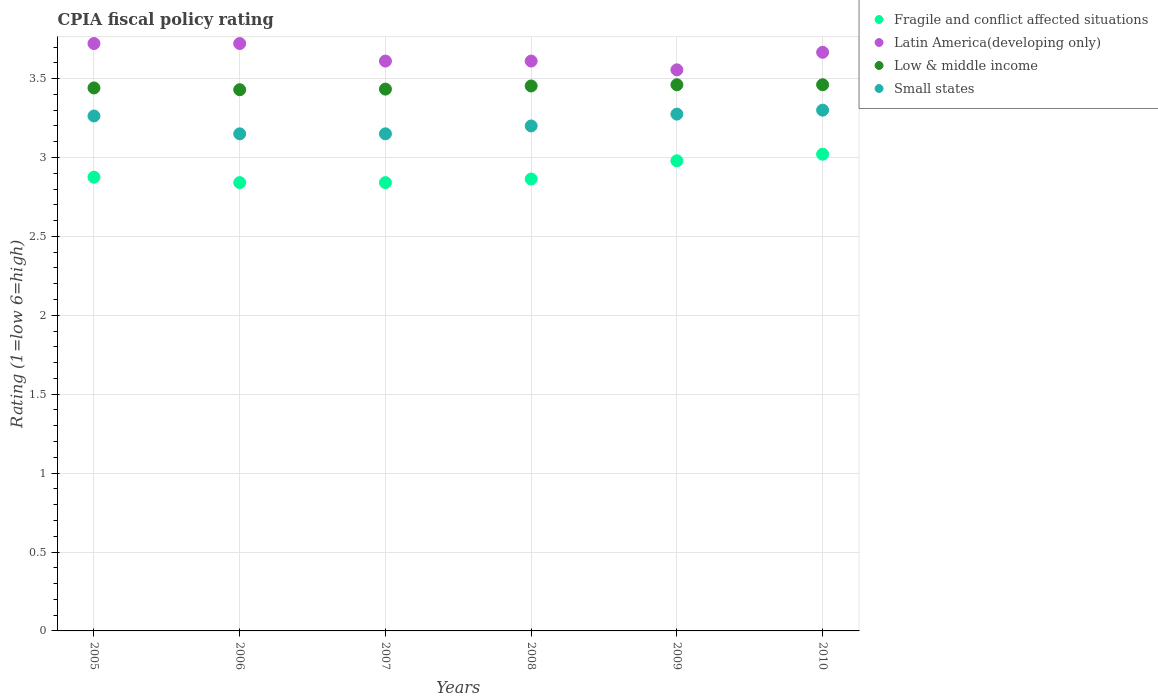How many different coloured dotlines are there?
Your response must be concise. 4. What is the CPIA rating in Low & middle income in 2006?
Offer a terse response. 3.43. Across all years, what is the minimum CPIA rating in Small states?
Your answer should be compact. 3.15. In which year was the CPIA rating in Small states minimum?
Provide a short and direct response. 2006. What is the total CPIA rating in Low & middle income in the graph?
Provide a short and direct response. 20.68. What is the difference between the CPIA rating in Latin America(developing only) in 2006 and that in 2008?
Keep it short and to the point. 0.11. What is the difference between the CPIA rating in Low & middle income in 2009 and the CPIA rating in Latin America(developing only) in 2010?
Offer a very short reply. -0.21. What is the average CPIA rating in Fragile and conflict affected situations per year?
Your answer should be very brief. 2.9. In the year 2006, what is the difference between the CPIA rating in Small states and CPIA rating in Low & middle income?
Ensure brevity in your answer.  -0.28. In how many years, is the CPIA rating in Low & middle income greater than 1.8?
Ensure brevity in your answer.  6. What is the ratio of the CPIA rating in Latin America(developing only) in 2009 to that in 2010?
Your response must be concise. 0.97. Is the difference between the CPIA rating in Small states in 2005 and 2007 greater than the difference between the CPIA rating in Low & middle income in 2005 and 2007?
Offer a terse response. Yes. What is the difference between the highest and the second highest CPIA rating in Fragile and conflict affected situations?
Give a very brief answer. 0.04. What is the difference between the highest and the lowest CPIA rating in Latin America(developing only)?
Offer a very short reply. 0.17. In how many years, is the CPIA rating in Fragile and conflict affected situations greater than the average CPIA rating in Fragile and conflict affected situations taken over all years?
Keep it short and to the point. 2. Is the sum of the CPIA rating in Low & middle income in 2008 and 2010 greater than the maximum CPIA rating in Latin America(developing only) across all years?
Ensure brevity in your answer.  Yes. Is it the case that in every year, the sum of the CPIA rating in Fragile and conflict affected situations and CPIA rating in Small states  is greater than the CPIA rating in Low & middle income?
Offer a very short reply. Yes. Is the CPIA rating in Low & middle income strictly greater than the CPIA rating in Latin America(developing only) over the years?
Keep it short and to the point. No. How many years are there in the graph?
Provide a short and direct response. 6. What is the difference between two consecutive major ticks on the Y-axis?
Provide a succinct answer. 0.5. Are the values on the major ticks of Y-axis written in scientific E-notation?
Give a very brief answer. No. Where does the legend appear in the graph?
Your answer should be compact. Top right. How are the legend labels stacked?
Make the answer very short. Vertical. What is the title of the graph?
Ensure brevity in your answer.  CPIA fiscal policy rating. Does "Middle income" appear as one of the legend labels in the graph?
Offer a terse response. No. What is the label or title of the X-axis?
Offer a very short reply. Years. What is the label or title of the Y-axis?
Offer a very short reply. Rating (1=low 6=high). What is the Rating (1=low 6=high) in Fragile and conflict affected situations in 2005?
Ensure brevity in your answer.  2.88. What is the Rating (1=low 6=high) of Latin America(developing only) in 2005?
Give a very brief answer. 3.72. What is the Rating (1=low 6=high) of Low & middle income in 2005?
Give a very brief answer. 3.44. What is the Rating (1=low 6=high) of Small states in 2005?
Provide a short and direct response. 3.26. What is the Rating (1=low 6=high) in Fragile and conflict affected situations in 2006?
Offer a very short reply. 2.84. What is the Rating (1=low 6=high) in Latin America(developing only) in 2006?
Make the answer very short. 3.72. What is the Rating (1=low 6=high) of Low & middle income in 2006?
Keep it short and to the point. 3.43. What is the Rating (1=low 6=high) in Small states in 2006?
Offer a terse response. 3.15. What is the Rating (1=low 6=high) of Fragile and conflict affected situations in 2007?
Your answer should be very brief. 2.84. What is the Rating (1=low 6=high) in Latin America(developing only) in 2007?
Make the answer very short. 3.61. What is the Rating (1=low 6=high) of Low & middle income in 2007?
Offer a terse response. 3.43. What is the Rating (1=low 6=high) in Small states in 2007?
Offer a terse response. 3.15. What is the Rating (1=low 6=high) of Fragile and conflict affected situations in 2008?
Give a very brief answer. 2.86. What is the Rating (1=low 6=high) of Latin America(developing only) in 2008?
Provide a short and direct response. 3.61. What is the Rating (1=low 6=high) of Low & middle income in 2008?
Your answer should be very brief. 3.45. What is the Rating (1=low 6=high) of Fragile and conflict affected situations in 2009?
Your answer should be very brief. 2.98. What is the Rating (1=low 6=high) in Latin America(developing only) in 2009?
Provide a short and direct response. 3.56. What is the Rating (1=low 6=high) of Low & middle income in 2009?
Offer a terse response. 3.46. What is the Rating (1=low 6=high) of Small states in 2009?
Ensure brevity in your answer.  3.27. What is the Rating (1=low 6=high) of Fragile and conflict affected situations in 2010?
Provide a short and direct response. 3.02. What is the Rating (1=low 6=high) in Latin America(developing only) in 2010?
Your response must be concise. 3.67. What is the Rating (1=low 6=high) of Low & middle income in 2010?
Your response must be concise. 3.46. What is the Rating (1=low 6=high) of Small states in 2010?
Offer a terse response. 3.3. Across all years, what is the maximum Rating (1=low 6=high) in Fragile and conflict affected situations?
Provide a succinct answer. 3.02. Across all years, what is the maximum Rating (1=low 6=high) in Latin America(developing only)?
Your answer should be compact. 3.72. Across all years, what is the maximum Rating (1=low 6=high) in Low & middle income?
Your answer should be compact. 3.46. Across all years, what is the minimum Rating (1=low 6=high) in Fragile and conflict affected situations?
Provide a succinct answer. 2.84. Across all years, what is the minimum Rating (1=low 6=high) of Latin America(developing only)?
Your answer should be compact. 3.56. Across all years, what is the minimum Rating (1=low 6=high) in Low & middle income?
Ensure brevity in your answer.  3.43. Across all years, what is the minimum Rating (1=low 6=high) of Small states?
Ensure brevity in your answer.  3.15. What is the total Rating (1=low 6=high) in Fragile and conflict affected situations in the graph?
Provide a short and direct response. 17.42. What is the total Rating (1=low 6=high) in Latin America(developing only) in the graph?
Keep it short and to the point. 21.89. What is the total Rating (1=low 6=high) in Low & middle income in the graph?
Keep it short and to the point. 20.68. What is the total Rating (1=low 6=high) in Small states in the graph?
Provide a short and direct response. 19.34. What is the difference between the Rating (1=low 6=high) of Fragile and conflict affected situations in 2005 and that in 2006?
Keep it short and to the point. 0.03. What is the difference between the Rating (1=low 6=high) in Low & middle income in 2005 and that in 2006?
Offer a very short reply. 0.01. What is the difference between the Rating (1=low 6=high) of Small states in 2005 and that in 2006?
Offer a very short reply. 0.11. What is the difference between the Rating (1=low 6=high) in Fragile and conflict affected situations in 2005 and that in 2007?
Provide a succinct answer. 0.03. What is the difference between the Rating (1=low 6=high) of Low & middle income in 2005 and that in 2007?
Make the answer very short. 0.01. What is the difference between the Rating (1=low 6=high) in Small states in 2005 and that in 2007?
Your answer should be compact. 0.11. What is the difference between the Rating (1=low 6=high) of Fragile and conflict affected situations in 2005 and that in 2008?
Give a very brief answer. 0.01. What is the difference between the Rating (1=low 6=high) in Low & middle income in 2005 and that in 2008?
Your response must be concise. -0.01. What is the difference between the Rating (1=low 6=high) of Small states in 2005 and that in 2008?
Your response must be concise. 0.06. What is the difference between the Rating (1=low 6=high) of Fragile and conflict affected situations in 2005 and that in 2009?
Provide a succinct answer. -0.1. What is the difference between the Rating (1=low 6=high) in Low & middle income in 2005 and that in 2009?
Keep it short and to the point. -0.02. What is the difference between the Rating (1=low 6=high) of Small states in 2005 and that in 2009?
Your answer should be very brief. -0.01. What is the difference between the Rating (1=low 6=high) in Fragile and conflict affected situations in 2005 and that in 2010?
Offer a terse response. -0.15. What is the difference between the Rating (1=low 6=high) in Latin America(developing only) in 2005 and that in 2010?
Give a very brief answer. 0.06. What is the difference between the Rating (1=low 6=high) of Low & middle income in 2005 and that in 2010?
Give a very brief answer. -0.02. What is the difference between the Rating (1=low 6=high) in Small states in 2005 and that in 2010?
Your answer should be compact. -0.04. What is the difference between the Rating (1=low 6=high) of Low & middle income in 2006 and that in 2007?
Offer a very short reply. -0. What is the difference between the Rating (1=low 6=high) of Small states in 2006 and that in 2007?
Keep it short and to the point. 0. What is the difference between the Rating (1=low 6=high) in Fragile and conflict affected situations in 2006 and that in 2008?
Offer a very short reply. -0.02. What is the difference between the Rating (1=low 6=high) in Latin America(developing only) in 2006 and that in 2008?
Give a very brief answer. 0.11. What is the difference between the Rating (1=low 6=high) of Low & middle income in 2006 and that in 2008?
Your answer should be compact. -0.02. What is the difference between the Rating (1=low 6=high) of Fragile and conflict affected situations in 2006 and that in 2009?
Keep it short and to the point. -0.14. What is the difference between the Rating (1=low 6=high) in Low & middle income in 2006 and that in 2009?
Offer a terse response. -0.03. What is the difference between the Rating (1=low 6=high) of Small states in 2006 and that in 2009?
Give a very brief answer. -0.12. What is the difference between the Rating (1=low 6=high) of Fragile and conflict affected situations in 2006 and that in 2010?
Keep it short and to the point. -0.18. What is the difference between the Rating (1=low 6=high) of Latin America(developing only) in 2006 and that in 2010?
Give a very brief answer. 0.06. What is the difference between the Rating (1=low 6=high) in Low & middle income in 2006 and that in 2010?
Ensure brevity in your answer.  -0.03. What is the difference between the Rating (1=low 6=high) of Fragile and conflict affected situations in 2007 and that in 2008?
Provide a short and direct response. -0.02. What is the difference between the Rating (1=low 6=high) of Latin America(developing only) in 2007 and that in 2008?
Offer a very short reply. 0. What is the difference between the Rating (1=low 6=high) of Low & middle income in 2007 and that in 2008?
Your response must be concise. -0.02. What is the difference between the Rating (1=low 6=high) of Small states in 2007 and that in 2008?
Your response must be concise. -0.05. What is the difference between the Rating (1=low 6=high) of Fragile and conflict affected situations in 2007 and that in 2009?
Keep it short and to the point. -0.14. What is the difference between the Rating (1=low 6=high) of Latin America(developing only) in 2007 and that in 2009?
Provide a succinct answer. 0.06. What is the difference between the Rating (1=low 6=high) of Low & middle income in 2007 and that in 2009?
Your answer should be compact. -0.03. What is the difference between the Rating (1=low 6=high) in Small states in 2007 and that in 2009?
Give a very brief answer. -0.12. What is the difference between the Rating (1=low 6=high) of Fragile and conflict affected situations in 2007 and that in 2010?
Ensure brevity in your answer.  -0.18. What is the difference between the Rating (1=low 6=high) of Latin America(developing only) in 2007 and that in 2010?
Make the answer very short. -0.06. What is the difference between the Rating (1=low 6=high) of Low & middle income in 2007 and that in 2010?
Your answer should be compact. -0.03. What is the difference between the Rating (1=low 6=high) in Small states in 2007 and that in 2010?
Keep it short and to the point. -0.15. What is the difference between the Rating (1=low 6=high) in Fragile and conflict affected situations in 2008 and that in 2009?
Provide a short and direct response. -0.12. What is the difference between the Rating (1=low 6=high) of Latin America(developing only) in 2008 and that in 2009?
Keep it short and to the point. 0.06. What is the difference between the Rating (1=low 6=high) of Low & middle income in 2008 and that in 2009?
Keep it short and to the point. -0.01. What is the difference between the Rating (1=low 6=high) in Small states in 2008 and that in 2009?
Keep it short and to the point. -0.07. What is the difference between the Rating (1=low 6=high) in Fragile and conflict affected situations in 2008 and that in 2010?
Offer a terse response. -0.16. What is the difference between the Rating (1=low 6=high) of Latin America(developing only) in 2008 and that in 2010?
Offer a very short reply. -0.06. What is the difference between the Rating (1=low 6=high) of Low & middle income in 2008 and that in 2010?
Your answer should be very brief. -0.01. What is the difference between the Rating (1=low 6=high) in Fragile and conflict affected situations in 2009 and that in 2010?
Your answer should be compact. -0.04. What is the difference between the Rating (1=low 6=high) of Latin America(developing only) in 2009 and that in 2010?
Offer a very short reply. -0.11. What is the difference between the Rating (1=low 6=high) of Low & middle income in 2009 and that in 2010?
Provide a succinct answer. 0. What is the difference between the Rating (1=low 6=high) in Small states in 2009 and that in 2010?
Offer a very short reply. -0.03. What is the difference between the Rating (1=low 6=high) in Fragile and conflict affected situations in 2005 and the Rating (1=low 6=high) in Latin America(developing only) in 2006?
Offer a very short reply. -0.85. What is the difference between the Rating (1=low 6=high) in Fragile and conflict affected situations in 2005 and the Rating (1=low 6=high) in Low & middle income in 2006?
Keep it short and to the point. -0.55. What is the difference between the Rating (1=low 6=high) in Fragile and conflict affected situations in 2005 and the Rating (1=low 6=high) in Small states in 2006?
Offer a terse response. -0.28. What is the difference between the Rating (1=low 6=high) in Latin America(developing only) in 2005 and the Rating (1=low 6=high) in Low & middle income in 2006?
Keep it short and to the point. 0.29. What is the difference between the Rating (1=low 6=high) in Latin America(developing only) in 2005 and the Rating (1=low 6=high) in Small states in 2006?
Ensure brevity in your answer.  0.57. What is the difference between the Rating (1=low 6=high) of Low & middle income in 2005 and the Rating (1=low 6=high) of Small states in 2006?
Make the answer very short. 0.29. What is the difference between the Rating (1=low 6=high) of Fragile and conflict affected situations in 2005 and the Rating (1=low 6=high) of Latin America(developing only) in 2007?
Offer a terse response. -0.74. What is the difference between the Rating (1=low 6=high) of Fragile and conflict affected situations in 2005 and the Rating (1=low 6=high) of Low & middle income in 2007?
Your answer should be very brief. -0.56. What is the difference between the Rating (1=low 6=high) of Fragile and conflict affected situations in 2005 and the Rating (1=low 6=high) of Small states in 2007?
Keep it short and to the point. -0.28. What is the difference between the Rating (1=low 6=high) of Latin America(developing only) in 2005 and the Rating (1=low 6=high) of Low & middle income in 2007?
Provide a succinct answer. 0.29. What is the difference between the Rating (1=low 6=high) in Latin America(developing only) in 2005 and the Rating (1=low 6=high) in Small states in 2007?
Your answer should be very brief. 0.57. What is the difference between the Rating (1=low 6=high) of Low & middle income in 2005 and the Rating (1=low 6=high) of Small states in 2007?
Make the answer very short. 0.29. What is the difference between the Rating (1=low 6=high) of Fragile and conflict affected situations in 2005 and the Rating (1=low 6=high) of Latin America(developing only) in 2008?
Provide a short and direct response. -0.74. What is the difference between the Rating (1=low 6=high) in Fragile and conflict affected situations in 2005 and the Rating (1=low 6=high) in Low & middle income in 2008?
Offer a terse response. -0.58. What is the difference between the Rating (1=low 6=high) in Fragile and conflict affected situations in 2005 and the Rating (1=low 6=high) in Small states in 2008?
Offer a terse response. -0.33. What is the difference between the Rating (1=low 6=high) in Latin America(developing only) in 2005 and the Rating (1=low 6=high) in Low & middle income in 2008?
Ensure brevity in your answer.  0.27. What is the difference between the Rating (1=low 6=high) of Latin America(developing only) in 2005 and the Rating (1=low 6=high) of Small states in 2008?
Your answer should be compact. 0.52. What is the difference between the Rating (1=low 6=high) of Low & middle income in 2005 and the Rating (1=low 6=high) of Small states in 2008?
Make the answer very short. 0.24. What is the difference between the Rating (1=low 6=high) of Fragile and conflict affected situations in 2005 and the Rating (1=low 6=high) of Latin America(developing only) in 2009?
Keep it short and to the point. -0.68. What is the difference between the Rating (1=low 6=high) of Fragile and conflict affected situations in 2005 and the Rating (1=low 6=high) of Low & middle income in 2009?
Your answer should be very brief. -0.59. What is the difference between the Rating (1=low 6=high) of Fragile and conflict affected situations in 2005 and the Rating (1=low 6=high) of Small states in 2009?
Offer a very short reply. -0.4. What is the difference between the Rating (1=low 6=high) in Latin America(developing only) in 2005 and the Rating (1=low 6=high) in Low & middle income in 2009?
Ensure brevity in your answer.  0.26. What is the difference between the Rating (1=low 6=high) of Latin America(developing only) in 2005 and the Rating (1=low 6=high) of Small states in 2009?
Offer a very short reply. 0.45. What is the difference between the Rating (1=low 6=high) in Low & middle income in 2005 and the Rating (1=low 6=high) in Small states in 2009?
Offer a very short reply. 0.17. What is the difference between the Rating (1=low 6=high) in Fragile and conflict affected situations in 2005 and the Rating (1=low 6=high) in Latin America(developing only) in 2010?
Make the answer very short. -0.79. What is the difference between the Rating (1=low 6=high) in Fragile and conflict affected situations in 2005 and the Rating (1=low 6=high) in Low & middle income in 2010?
Keep it short and to the point. -0.59. What is the difference between the Rating (1=low 6=high) in Fragile and conflict affected situations in 2005 and the Rating (1=low 6=high) in Small states in 2010?
Your answer should be very brief. -0.42. What is the difference between the Rating (1=low 6=high) in Latin America(developing only) in 2005 and the Rating (1=low 6=high) in Low & middle income in 2010?
Keep it short and to the point. 0.26. What is the difference between the Rating (1=low 6=high) in Latin America(developing only) in 2005 and the Rating (1=low 6=high) in Small states in 2010?
Offer a very short reply. 0.42. What is the difference between the Rating (1=low 6=high) in Low & middle income in 2005 and the Rating (1=low 6=high) in Small states in 2010?
Offer a very short reply. 0.14. What is the difference between the Rating (1=low 6=high) of Fragile and conflict affected situations in 2006 and the Rating (1=low 6=high) of Latin America(developing only) in 2007?
Ensure brevity in your answer.  -0.77. What is the difference between the Rating (1=low 6=high) in Fragile and conflict affected situations in 2006 and the Rating (1=low 6=high) in Low & middle income in 2007?
Provide a short and direct response. -0.59. What is the difference between the Rating (1=low 6=high) of Fragile and conflict affected situations in 2006 and the Rating (1=low 6=high) of Small states in 2007?
Ensure brevity in your answer.  -0.31. What is the difference between the Rating (1=low 6=high) of Latin America(developing only) in 2006 and the Rating (1=low 6=high) of Low & middle income in 2007?
Keep it short and to the point. 0.29. What is the difference between the Rating (1=low 6=high) in Latin America(developing only) in 2006 and the Rating (1=low 6=high) in Small states in 2007?
Your answer should be compact. 0.57. What is the difference between the Rating (1=low 6=high) of Low & middle income in 2006 and the Rating (1=low 6=high) of Small states in 2007?
Your answer should be very brief. 0.28. What is the difference between the Rating (1=low 6=high) of Fragile and conflict affected situations in 2006 and the Rating (1=low 6=high) of Latin America(developing only) in 2008?
Ensure brevity in your answer.  -0.77. What is the difference between the Rating (1=low 6=high) in Fragile and conflict affected situations in 2006 and the Rating (1=low 6=high) in Low & middle income in 2008?
Provide a short and direct response. -0.61. What is the difference between the Rating (1=low 6=high) in Fragile and conflict affected situations in 2006 and the Rating (1=low 6=high) in Small states in 2008?
Keep it short and to the point. -0.36. What is the difference between the Rating (1=low 6=high) of Latin America(developing only) in 2006 and the Rating (1=low 6=high) of Low & middle income in 2008?
Provide a succinct answer. 0.27. What is the difference between the Rating (1=low 6=high) in Latin America(developing only) in 2006 and the Rating (1=low 6=high) in Small states in 2008?
Your answer should be very brief. 0.52. What is the difference between the Rating (1=low 6=high) in Low & middle income in 2006 and the Rating (1=low 6=high) in Small states in 2008?
Offer a terse response. 0.23. What is the difference between the Rating (1=low 6=high) in Fragile and conflict affected situations in 2006 and the Rating (1=low 6=high) in Latin America(developing only) in 2009?
Ensure brevity in your answer.  -0.71. What is the difference between the Rating (1=low 6=high) of Fragile and conflict affected situations in 2006 and the Rating (1=low 6=high) of Low & middle income in 2009?
Provide a succinct answer. -0.62. What is the difference between the Rating (1=low 6=high) of Fragile and conflict affected situations in 2006 and the Rating (1=low 6=high) of Small states in 2009?
Your answer should be compact. -0.43. What is the difference between the Rating (1=low 6=high) in Latin America(developing only) in 2006 and the Rating (1=low 6=high) in Low & middle income in 2009?
Keep it short and to the point. 0.26. What is the difference between the Rating (1=low 6=high) in Latin America(developing only) in 2006 and the Rating (1=low 6=high) in Small states in 2009?
Keep it short and to the point. 0.45. What is the difference between the Rating (1=low 6=high) of Low & middle income in 2006 and the Rating (1=low 6=high) of Small states in 2009?
Keep it short and to the point. 0.15. What is the difference between the Rating (1=low 6=high) in Fragile and conflict affected situations in 2006 and the Rating (1=low 6=high) in Latin America(developing only) in 2010?
Offer a very short reply. -0.83. What is the difference between the Rating (1=low 6=high) in Fragile and conflict affected situations in 2006 and the Rating (1=low 6=high) in Low & middle income in 2010?
Provide a succinct answer. -0.62. What is the difference between the Rating (1=low 6=high) of Fragile and conflict affected situations in 2006 and the Rating (1=low 6=high) of Small states in 2010?
Keep it short and to the point. -0.46. What is the difference between the Rating (1=low 6=high) in Latin America(developing only) in 2006 and the Rating (1=low 6=high) in Low & middle income in 2010?
Ensure brevity in your answer.  0.26. What is the difference between the Rating (1=low 6=high) in Latin America(developing only) in 2006 and the Rating (1=low 6=high) in Small states in 2010?
Your answer should be compact. 0.42. What is the difference between the Rating (1=low 6=high) of Low & middle income in 2006 and the Rating (1=low 6=high) of Small states in 2010?
Keep it short and to the point. 0.13. What is the difference between the Rating (1=low 6=high) in Fragile and conflict affected situations in 2007 and the Rating (1=low 6=high) in Latin America(developing only) in 2008?
Offer a very short reply. -0.77. What is the difference between the Rating (1=low 6=high) in Fragile and conflict affected situations in 2007 and the Rating (1=low 6=high) in Low & middle income in 2008?
Your answer should be very brief. -0.61. What is the difference between the Rating (1=low 6=high) in Fragile and conflict affected situations in 2007 and the Rating (1=low 6=high) in Small states in 2008?
Provide a succinct answer. -0.36. What is the difference between the Rating (1=low 6=high) in Latin America(developing only) in 2007 and the Rating (1=low 6=high) in Low & middle income in 2008?
Make the answer very short. 0.16. What is the difference between the Rating (1=low 6=high) in Latin America(developing only) in 2007 and the Rating (1=low 6=high) in Small states in 2008?
Provide a short and direct response. 0.41. What is the difference between the Rating (1=low 6=high) in Low & middle income in 2007 and the Rating (1=low 6=high) in Small states in 2008?
Your answer should be compact. 0.23. What is the difference between the Rating (1=low 6=high) of Fragile and conflict affected situations in 2007 and the Rating (1=low 6=high) of Latin America(developing only) in 2009?
Provide a succinct answer. -0.71. What is the difference between the Rating (1=low 6=high) in Fragile and conflict affected situations in 2007 and the Rating (1=low 6=high) in Low & middle income in 2009?
Make the answer very short. -0.62. What is the difference between the Rating (1=low 6=high) of Fragile and conflict affected situations in 2007 and the Rating (1=low 6=high) of Small states in 2009?
Ensure brevity in your answer.  -0.43. What is the difference between the Rating (1=low 6=high) of Latin America(developing only) in 2007 and the Rating (1=low 6=high) of Low & middle income in 2009?
Provide a short and direct response. 0.15. What is the difference between the Rating (1=low 6=high) of Latin America(developing only) in 2007 and the Rating (1=low 6=high) of Small states in 2009?
Your answer should be very brief. 0.34. What is the difference between the Rating (1=low 6=high) of Low & middle income in 2007 and the Rating (1=low 6=high) of Small states in 2009?
Provide a short and direct response. 0.16. What is the difference between the Rating (1=low 6=high) of Fragile and conflict affected situations in 2007 and the Rating (1=low 6=high) of Latin America(developing only) in 2010?
Your response must be concise. -0.83. What is the difference between the Rating (1=low 6=high) in Fragile and conflict affected situations in 2007 and the Rating (1=low 6=high) in Low & middle income in 2010?
Make the answer very short. -0.62. What is the difference between the Rating (1=low 6=high) of Fragile and conflict affected situations in 2007 and the Rating (1=low 6=high) of Small states in 2010?
Give a very brief answer. -0.46. What is the difference between the Rating (1=low 6=high) in Latin America(developing only) in 2007 and the Rating (1=low 6=high) in Low & middle income in 2010?
Give a very brief answer. 0.15. What is the difference between the Rating (1=low 6=high) in Latin America(developing only) in 2007 and the Rating (1=low 6=high) in Small states in 2010?
Keep it short and to the point. 0.31. What is the difference between the Rating (1=low 6=high) of Low & middle income in 2007 and the Rating (1=low 6=high) of Small states in 2010?
Provide a short and direct response. 0.13. What is the difference between the Rating (1=low 6=high) of Fragile and conflict affected situations in 2008 and the Rating (1=low 6=high) of Latin America(developing only) in 2009?
Make the answer very short. -0.69. What is the difference between the Rating (1=low 6=high) in Fragile and conflict affected situations in 2008 and the Rating (1=low 6=high) in Low & middle income in 2009?
Your response must be concise. -0.6. What is the difference between the Rating (1=low 6=high) of Fragile and conflict affected situations in 2008 and the Rating (1=low 6=high) of Small states in 2009?
Offer a terse response. -0.41. What is the difference between the Rating (1=low 6=high) of Latin America(developing only) in 2008 and the Rating (1=low 6=high) of Low & middle income in 2009?
Provide a succinct answer. 0.15. What is the difference between the Rating (1=low 6=high) in Latin America(developing only) in 2008 and the Rating (1=low 6=high) in Small states in 2009?
Ensure brevity in your answer.  0.34. What is the difference between the Rating (1=low 6=high) in Low & middle income in 2008 and the Rating (1=low 6=high) in Small states in 2009?
Give a very brief answer. 0.18. What is the difference between the Rating (1=low 6=high) of Fragile and conflict affected situations in 2008 and the Rating (1=low 6=high) of Latin America(developing only) in 2010?
Your answer should be very brief. -0.8. What is the difference between the Rating (1=low 6=high) in Fragile and conflict affected situations in 2008 and the Rating (1=low 6=high) in Low & middle income in 2010?
Keep it short and to the point. -0.6. What is the difference between the Rating (1=low 6=high) in Fragile and conflict affected situations in 2008 and the Rating (1=low 6=high) in Small states in 2010?
Offer a very short reply. -0.44. What is the difference between the Rating (1=low 6=high) in Latin America(developing only) in 2008 and the Rating (1=low 6=high) in Low & middle income in 2010?
Keep it short and to the point. 0.15. What is the difference between the Rating (1=low 6=high) in Latin America(developing only) in 2008 and the Rating (1=low 6=high) in Small states in 2010?
Your response must be concise. 0.31. What is the difference between the Rating (1=low 6=high) of Low & middle income in 2008 and the Rating (1=low 6=high) of Small states in 2010?
Keep it short and to the point. 0.15. What is the difference between the Rating (1=low 6=high) in Fragile and conflict affected situations in 2009 and the Rating (1=low 6=high) in Latin America(developing only) in 2010?
Provide a short and direct response. -0.69. What is the difference between the Rating (1=low 6=high) of Fragile and conflict affected situations in 2009 and the Rating (1=low 6=high) of Low & middle income in 2010?
Provide a succinct answer. -0.48. What is the difference between the Rating (1=low 6=high) in Fragile and conflict affected situations in 2009 and the Rating (1=low 6=high) in Small states in 2010?
Offer a terse response. -0.32. What is the difference between the Rating (1=low 6=high) in Latin America(developing only) in 2009 and the Rating (1=low 6=high) in Low & middle income in 2010?
Your response must be concise. 0.09. What is the difference between the Rating (1=low 6=high) of Latin America(developing only) in 2009 and the Rating (1=low 6=high) of Small states in 2010?
Make the answer very short. 0.26. What is the difference between the Rating (1=low 6=high) of Low & middle income in 2009 and the Rating (1=low 6=high) of Small states in 2010?
Your answer should be very brief. 0.16. What is the average Rating (1=low 6=high) of Fragile and conflict affected situations per year?
Provide a succinct answer. 2.9. What is the average Rating (1=low 6=high) in Latin America(developing only) per year?
Offer a very short reply. 3.65. What is the average Rating (1=low 6=high) in Low & middle income per year?
Your answer should be very brief. 3.45. What is the average Rating (1=low 6=high) of Small states per year?
Offer a very short reply. 3.22. In the year 2005, what is the difference between the Rating (1=low 6=high) in Fragile and conflict affected situations and Rating (1=low 6=high) in Latin America(developing only)?
Your answer should be very brief. -0.85. In the year 2005, what is the difference between the Rating (1=low 6=high) in Fragile and conflict affected situations and Rating (1=low 6=high) in Low & middle income?
Keep it short and to the point. -0.57. In the year 2005, what is the difference between the Rating (1=low 6=high) of Fragile and conflict affected situations and Rating (1=low 6=high) of Small states?
Make the answer very short. -0.39. In the year 2005, what is the difference between the Rating (1=low 6=high) of Latin America(developing only) and Rating (1=low 6=high) of Low & middle income?
Offer a very short reply. 0.28. In the year 2005, what is the difference between the Rating (1=low 6=high) of Latin America(developing only) and Rating (1=low 6=high) of Small states?
Keep it short and to the point. 0.46. In the year 2005, what is the difference between the Rating (1=low 6=high) in Low & middle income and Rating (1=low 6=high) in Small states?
Your answer should be very brief. 0.18. In the year 2006, what is the difference between the Rating (1=low 6=high) of Fragile and conflict affected situations and Rating (1=low 6=high) of Latin America(developing only)?
Ensure brevity in your answer.  -0.88. In the year 2006, what is the difference between the Rating (1=low 6=high) of Fragile and conflict affected situations and Rating (1=low 6=high) of Low & middle income?
Offer a terse response. -0.59. In the year 2006, what is the difference between the Rating (1=low 6=high) in Fragile and conflict affected situations and Rating (1=low 6=high) in Small states?
Your answer should be very brief. -0.31. In the year 2006, what is the difference between the Rating (1=low 6=high) of Latin America(developing only) and Rating (1=low 6=high) of Low & middle income?
Offer a very short reply. 0.29. In the year 2006, what is the difference between the Rating (1=low 6=high) of Latin America(developing only) and Rating (1=low 6=high) of Small states?
Offer a very short reply. 0.57. In the year 2006, what is the difference between the Rating (1=low 6=high) of Low & middle income and Rating (1=low 6=high) of Small states?
Your response must be concise. 0.28. In the year 2007, what is the difference between the Rating (1=low 6=high) in Fragile and conflict affected situations and Rating (1=low 6=high) in Latin America(developing only)?
Keep it short and to the point. -0.77. In the year 2007, what is the difference between the Rating (1=low 6=high) in Fragile and conflict affected situations and Rating (1=low 6=high) in Low & middle income?
Offer a very short reply. -0.59. In the year 2007, what is the difference between the Rating (1=low 6=high) in Fragile and conflict affected situations and Rating (1=low 6=high) in Small states?
Provide a succinct answer. -0.31. In the year 2007, what is the difference between the Rating (1=low 6=high) of Latin America(developing only) and Rating (1=low 6=high) of Low & middle income?
Offer a very short reply. 0.18. In the year 2007, what is the difference between the Rating (1=low 6=high) in Latin America(developing only) and Rating (1=low 6=high) in Small states?
Offer a very short reply. 0.46. In the year 2007, what is the difference between the Rating (1=low 6=high) in Low & middle income and Rating (1=low 6=high) in Small states?
Your answer should be compact. 0.28. In the year 2008, what is the difference between the Rating (1=low 6=high) of Fragile and conflict affected situations and Rating (1=low 6=high) of Latin America(developing only)?
Keep it short and to the point. -0.75. In the year 2008, what is the difference between the Rating (1=low 6=high) in Fragile and conflict affected situations and Rating (1=low 6=high) in Low & middle income?
Provide a short and direct response. -0.59. In the year 2008, what is the difference between the Rating (1=low 6=high) in Fragile and conflict affected situations and Rating (1=low 6=high) in Small states?
Provide a succinct answer. -0.34. In the year 2008, what is the difference between the Rating (1=low 6=high) of Latin America(developing only) and Rating (1=low 6=high) of Low & middle income?
Keep it short and to the point. 0.16. In the year 2008, what is the difference between the Rating (1=low 6=high) in Latin America(developing only) and Rating (1=low 6=high) in Small states?
Offer a terse response. 0.41. In the year 2008, what is the difference between the Rating (1=low 6=high) in Low & middle income and Rating (1=low 6=high) in Small states?
Your answer should be very brief. 0.25. In the year 2009, what is the difference between the Rating (1=low 6=high) of Fragile and conflict affected situations and Rating (1=low 6=high) of Latin America(developing only)?
Give a very brief answer. -0.58. In the year 2009, what is the difference between the Rating (1=low 6=high) of Fragile and conflict affected situations and Rating (1=low 6=high) of Low & middle income?
Make the answer very short. -0.48. In the year 2009, what is the difference between the Rating (1=low 6=high) in Fragile and conflict affected situations and Rating (1=low 6=high) in Small states?
Offer a very short reply. -0.3. In the year 2009, what is the difference between the Rating (1=low 6=high) in Latin America(developing only) and Rating (1=low 6=high) in Low & middle income?
Your answer should be very brief. 0.09. In the year 2009, what is the difference between the Rating (1=low 6=high) of Latin America(developing only) and Rating (1=low 6=high) of Small states?
Provide a succinct answer. 0.28. In the year 2009, what is the difference between the Rating (1=low 6=high) in Low & middle income and Rating (1=low 6=high) in Small states?
Your response must be concise. 0.19. In the year 2010, what is the difference between the Rating (1=low 6=high) in Fragile and conflict affected situations and Rating (1=low 6=high) in Latin America(developing only)?
Your response must be concise. -0.65. In the year 2010, what is the difference between the Rating (1=low 6=high) in Fragile and conflict affected situations and Rating (1=low 6=high) in Low & middle income?
Your response must be concise. -0.44. In the year 2010, what is the difference between the Rating (1=low 6=high) in Fragile and conflict affected situations and Rating (1=low 6=high) in Small states?
Keep it short and to the point. -0.28. In the year 2010, what is the difference between the Rating (1=low 6=high) in Latin America(developing only) and Rating (1=low 6=high) in Low & middle income?
Your answer should be compact. 0.21. In the year 2010, what is the difference between the Rating (1=low 6=high) in Latin America(developing only) and Rating (1=low 6=high) in Small states?
Your answer should be very brief. 0.37. In the year 2010, what is the difference between the Rating (1=low 6=high) of Low & middle income and Rating (1=low 6=high) of Small states?
Provide a succinct answer. 0.16. What is the ratio of the Rating (1=low 6=high) of Latin America(developing only) in 2005 to that in 2006?
Your answer should be compact. 1. What is the ratio of the Rating (1=low 6=high) of Low & middle income in 2005 to that in 2006?
Your answer should be very brief. 1. What is the ratio of the Rating (1=low 6=high) of Small states in 2005 to that in 2006?
Provide a succinct answer. 1.04. What is the ratio of the Rating (1=low 6=high) in Fragile and conflict affected situations in 2005 to that in 2007?
Your response must be concise. 1.01. What is the ratio of the Rating (1=low 6=high) of Latin America(developing only) in 2005 to that in 2007?
Ensure brevity in your answer.  1.03. What is the ratio of the Rating (1=low 6=high) in Small states in 2005 to that in 2007?
Your answer should be very brief. 1.04. What is the ratio of the Rating (1=low 6=high) of Latin America(developing only) in 2005 to that in 2008?
Give a very brief answer. 1.03. What is the ratio of the Rating (1=low 6=high) of Low & middle income in 2005 to that in 2008?
Your answer should be very brief. 1. What is the ratio of the Rating (1=low 6=high) of Small states in 2005 to that in 2008?
Keep it short and to the point. 1.02. What is the ratio of the Rating (1=low 6=high) of Latin America(developing only) in 2005 to that in 2009?
Ensure brevity in your answer.  1.05. What is the ratio of the Rating (1=low 6=high) of Fragile and conflict affected situations in 2005 to that in 2010?
Offer a very short reply. 0.95. What is the ratio of the Rating (1=low 6=high) of Latin America(developing only) in 2005 to that in 2010?
Offer a very short reply. 1.02. What is the ratio of the Rating (1=low 6=high) of Low & middle income in 2005 to that in 2010?
Make the answer very short. 0.99. What is the ratio of the Rating (1=low 6=high) in Small states in 2005 to that in 2010?
Provide a short and direct response. 0.99. What is the ratio of the Rating (1=low 6=high) in Latin America(developing only) in 2006 to that in 2007?
Ensure brevity in your answer.  1.03. What is the ratio of the Rating (1=low 6=high) of Low & middle income in 2006 to that in 2007?
Your response must be concise. 1. What is the ratio of the Rating (1=low 6=high) in Small states in 2006 to that in 2007?
Ensure brevity in your answer.  1. What is the ratio of the Rating (1=low 6=high) in Latin America(developing only) in 2006 to that in 2008?
Keep it short and to the point. 1.03. What is the ratio of the Rating (1=low 6=high) in Low & middle income in 2006 to that in 2008?
Your answer should be very brief. 0.99. What is the ratio of the Rating (1=low 6=high) in Small states in 2006 to that in 2008?
Offer a terse response. 0.98. What is the ratio of the Rating (1=low 6=high) in Fragile and conflict affected situations in 2006 to that in 2009?
Ensure brevity in your answer.  0.95. What is the ratio of the Rating (1=low 6=high) of Latin America(developing only) in 2006 to that in 2009?
Your answer should be compact. 1.05. What is the ratio of the Rating (1=low 6=high) of Low & middle income in 2006 to that in 2009?
Keep it short and to the point. 0.99. What is the ratio of the Rating (1=low 6=high) of Small states in 2006 to that in 2009?
Your answer should be very brief. 0.96. What is the ratio of the Rating (1=low 6=high) of Fragile and conflict affected situations in 2006 to that in 2010?
Give a very brief answer. 0.94. What is the ratio of the Rating (1=low 6=high) in Latin America(developing only) in 2006 to that in 2010?
Keep it short and to the point. 1.02. What is the ratio of the Rating (1=low 6=high) in Low & middle income in 2006 to that in 2010?
Your answer should be compact. 0.99. What is the ratio of the Rating (1=low 6=high) in Small states in 2006 to that in 2010?
Your response must be concise. 0.95. What is the ratio of the Rating (1=low 6=high) of Latin America(developing only) in 2007 to that in 2008?
Offer a very short reply. 1. What is the ratio of the Rating (1=low 6=high) of Small states in 2007 to that in 2008?
Your answer should be compact. 0.98. What is the ratio of the Rating (1=low 6=high) in Fragile and conflict affected situations in 2007 to that in 2009?
Offer a terse response. 0.95. What is the ratio of the Rating (1=low 6=high) in Latin America(developing only) in 2007 to that in 2009?
Your answer should be very brief. 1.02. What is the ratio of the Rating (1=low 6=high) of Small states in 2007 to that in 2009?
Provide a succinct answer. 0.96. What is the ratio of the Rating (1=low 6=high) in Fragile and conflict affected situations in 2007 to that in 2010?
Offer a very short reply. 0.94. What is the ratio of the Rating (1=low 6=high) in Low & middle income in 2007 to that in 2010?
Ensure brevity in your answer.  0.99. What is the ratio of the Rating (1=low 6=high) of Small states in 2007 to that in 2010?
Offer a very short reply. 0.95. What is the ratio of the Rating (1=low 6=high) of Fragile and conflict affected situations in 2008 to that in 2009?
Provide a short and direct response. 0.96. What is the ratio of the Rating (1=low 6=high) of Latin America(developing only) in 2008 to that in 2009?
Keep it short and to the point. 1.02. What is the ratio of the Rating (1=low 6=high) of Low & middle income in 2008 to that in 2009?
Provide a short and direct response. 1. What is the ratio of the Rating (1=low 6=high) of Small states in 2008 to that in 2009?
Offer a terse response. 0.98. What is the ratio of the Rating (1=low 6=high) in Fragile and conflict affected situations in 2008 to that in 2010?
Offer a terse response. 0.95. What is the ratio of the Rating (1=low 6=high) of Latin America(developing only) in 2008 to that in 2010?
Your answer should be compact. 0.98. What is the ratio of the Rating (1=low 6=high) of Low & middle income in 2008 to that in 2010?
Ensure brevity in your answer.  1. What is the ratio of the Rating (1=low 6=high) in Small states in 2008 to that in 2010?
Give a very brief answer. 0.97. What is the ratio of the Rating (1=low 6=high) in Fragile and conflict affected situations in 2009 to that in 2010?
Give a very brief answer. 0.99. What is the ratio of the Rating (1=low 6=high) of Latin America(developing only) in 2009 to that in 2010?
Your response must be concise. 0.97. What is the ratio of the Rating (1=low 6=high) in Low & middle income in 2009 to that in 2010?
Your answer should be very brief. 1. What is the difference between the highest and the second highest Rating (1=low 6=high) in Fragile and conflict affected situations?
Provide a short and direct response. 0.04. What is the difference between the highest and the second highest Rating (1=low 6=high) in Latin America(developing only)?
Ensure brevity in your answer.  0. What is the difference between the highest and the second highest Rating (1=low 6=high) of Low & middle income?
Your answer should be compact. 0. What is the difference between the highest and the second highest Rating (1=low 6=high) of Small states?
Provide a succinct answer. 0.03. What is the difference between the highest and the lowest Rating (1=low 6=high) of Fragile and conflict affected situations?
Keep it short and to the point. 0.18. What is the difference between the highest and the lowest Rating (1=low 6=high) in Latin America(developing only)?
Give a very brief answer. 0.17. What is the difference between the highest and the lowest Rating (1=low 6=high) in Low & middle income?
Your answer should be compact. 0.03. What is the difference between the highest and the lowest Rating (1=low 6=high) in Small states?
Offer a very short reply. 0.15. 